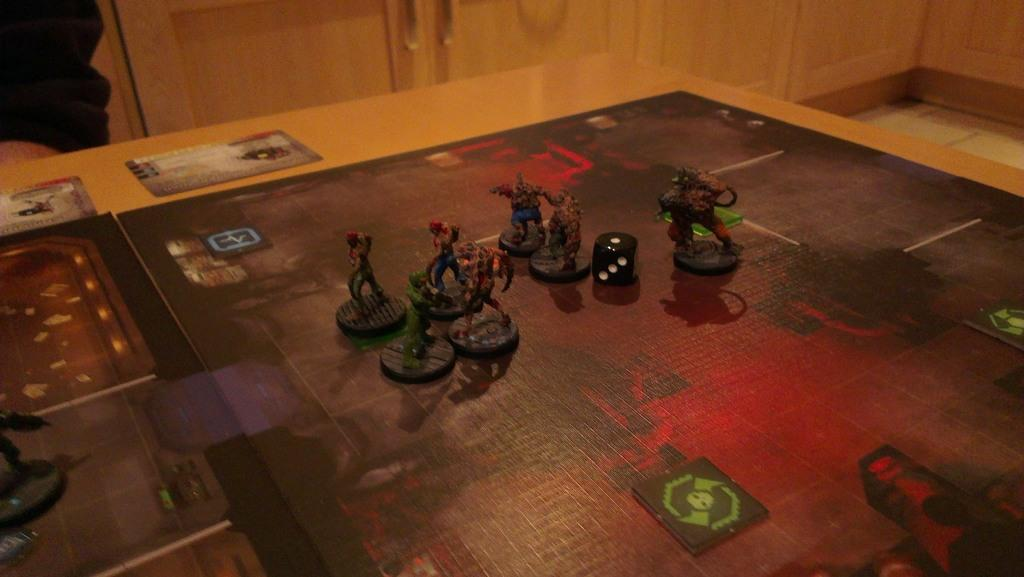What is the main object in the image? There is a chart in the image. What is placed on top of the chart? Toys and dice are placed on top of the chart. What type of table is in the image? There is a wooden table in the image. Can you describe any additional items in the image? There is a sticker, a wooden door, and a holder visible in the image. What can be seen on the floor in the image? The floor is visible in the image. What is located in the left corner of the image? There is a cloth and a human hand in the left corner of the image. What type of tomatoes are being used in the battle depicted in the image? There is no battle or tomatoes present in the image; it features a chart with toys and dice on top of it, along with other items. 